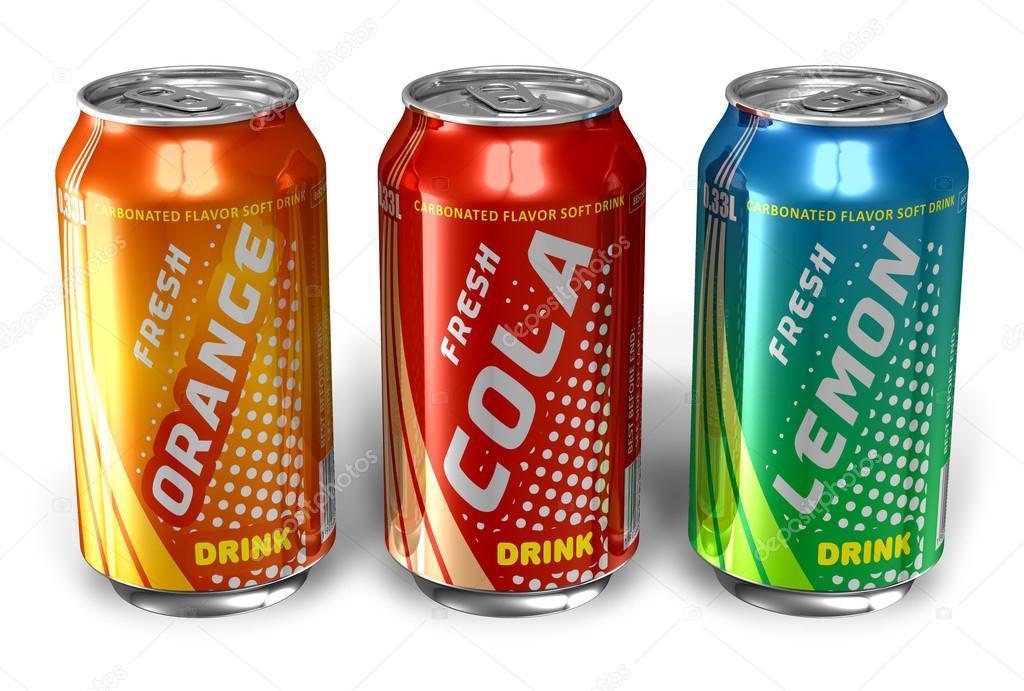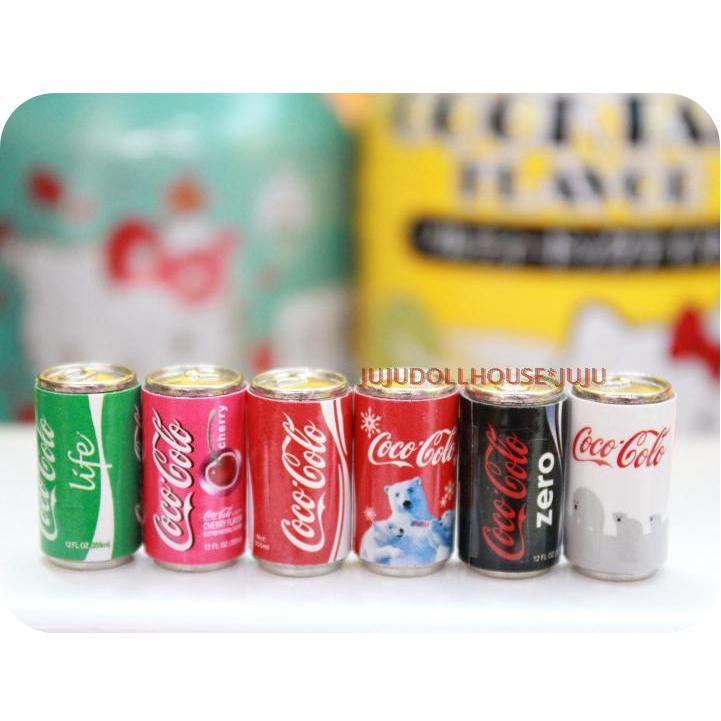The first image is the image on the left, the second image is the image on the right. Evaluate the accuracy of this statement regarding the images: "In one of the images there are only bottles of drinks.". Is it true? Answer yes or no. No. The first image is the image on the left, the second image is the image on the right. Assess this claim about the two images: "The left image contains at least three cans of soda.". Correct or not? Answer yes or no. Yes. 